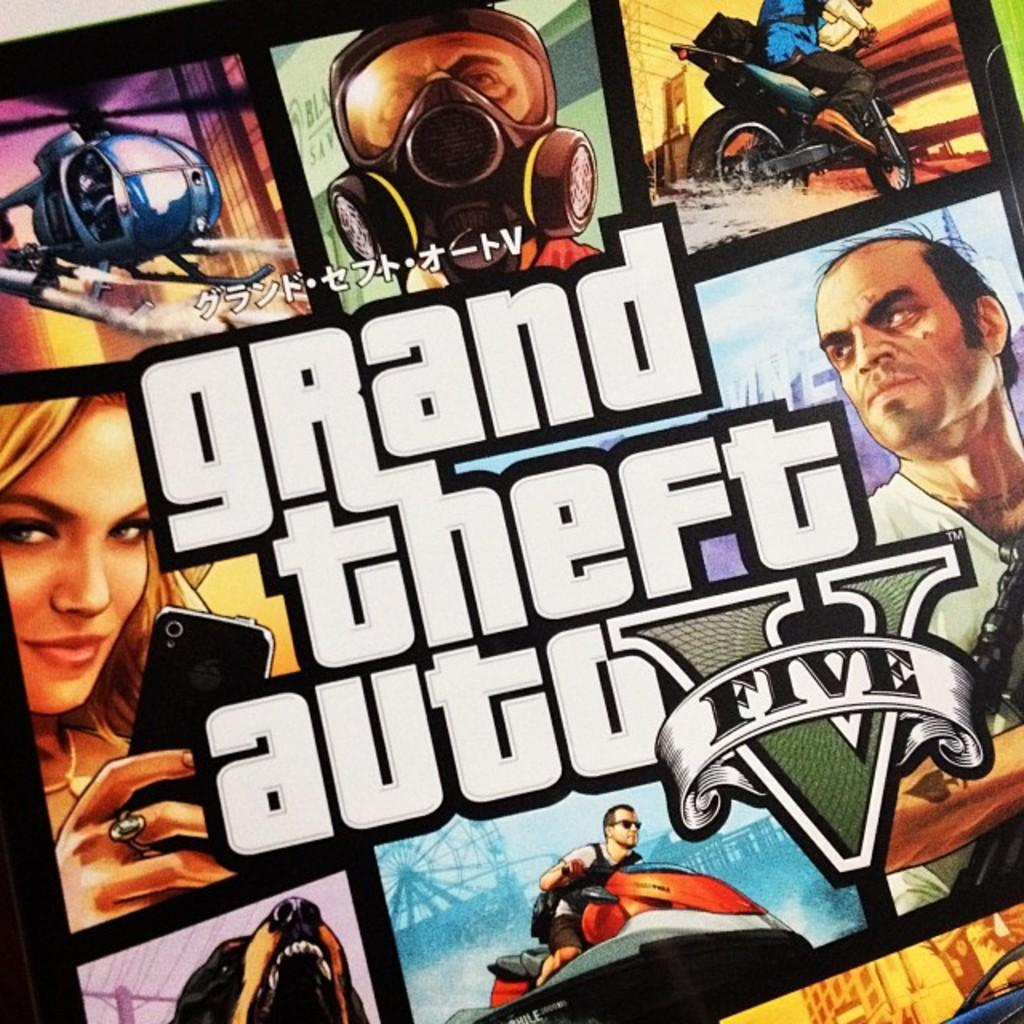What type of picture is in the image? The image contains an animated picture. Is there any branding or identification in the image? Yes, there is a logo in the image. Are there any words or phrases in the image? Yes, there is text in the image. How many legs can be seen on the truck in the image? There is no truck present in the image, so it is not possible to determine the number of legs. 